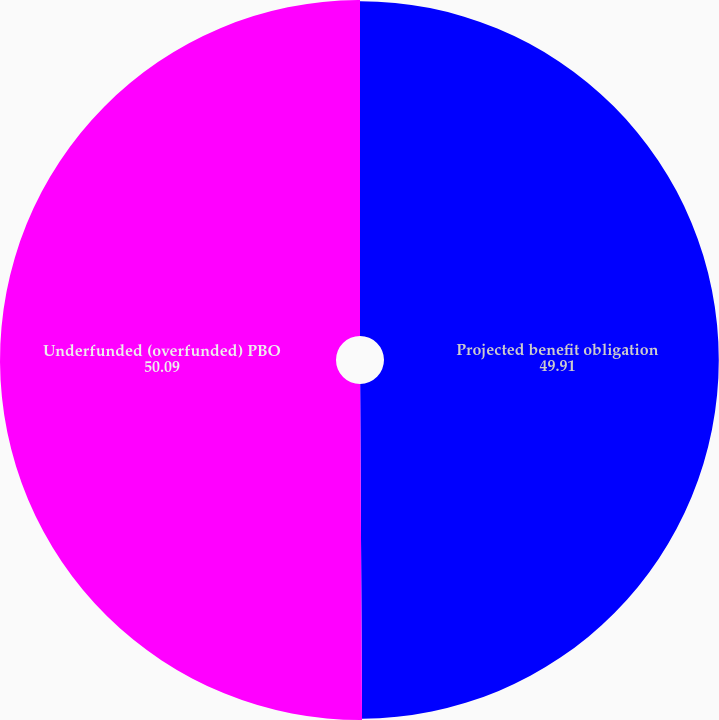Convert chart. <chart><loc_0><loc_0><loc_500><loc_500><pie_chart><fcel>Projected benefit obligation<fcel>Underfunded (overfunded) PBO<nl><fcel>49.91%<fcel>50.09%<nl></chart> 